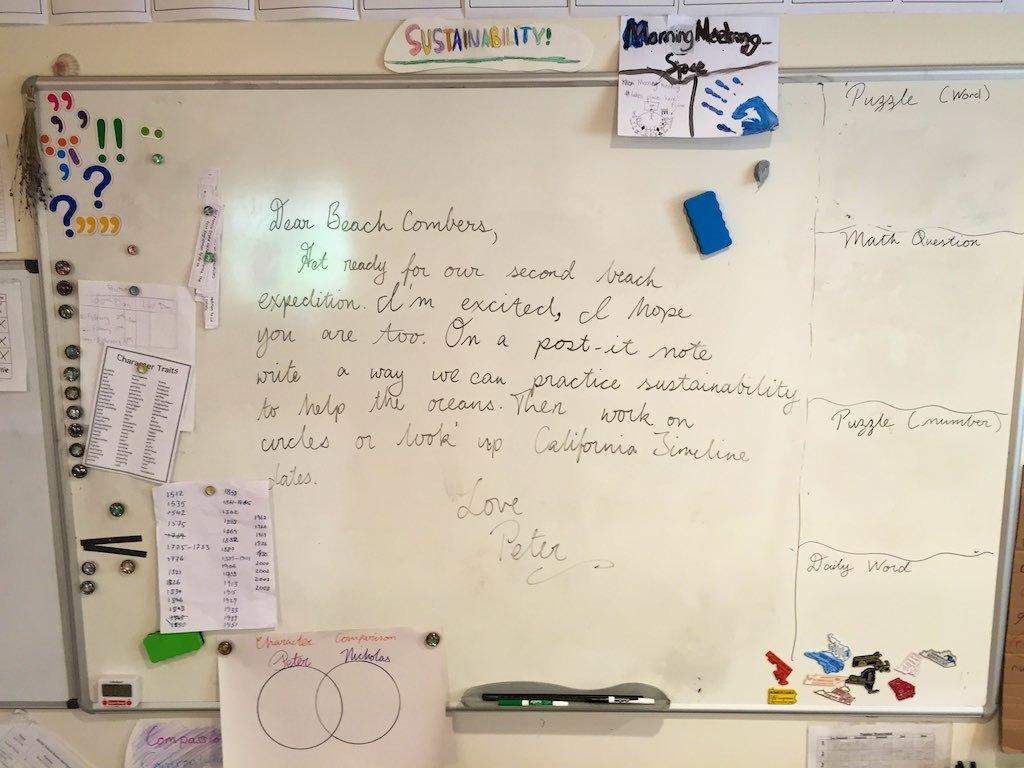Who signed the board?
Make the answer very short. Peter. 